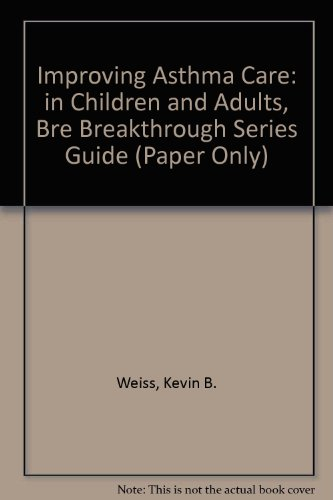Is this a judicial book? No, this is not a judicial book; it pertains to medical health care, specifically focusing on asthma care in children and adults. 